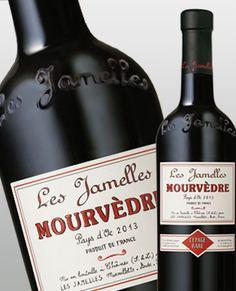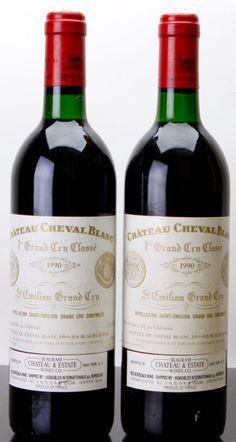The first image is the image on the left, the second image is the image on the right. For the images displayed, is the sentence "There is a wine glass visible on one of the images." factually correct? Answer yes or no. No. 